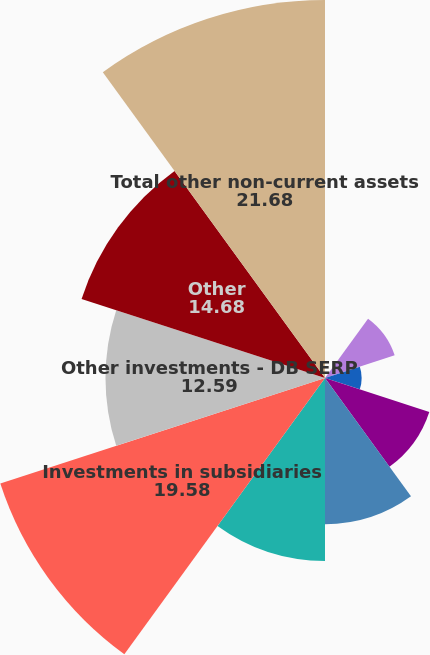Convert chart to OTSL. <chart><loc_0><loc_0><loc_500><loc_500><pie_chart><fcel>Notes and accrued interest<fcel>Accounts receivable including<fcel>Deferred income taxes<fcel>Total current assets<fcel>Plant property and equipment<fcel>Less accumulated depreciation<fcel>Investments in subsidiaries<fcel>Other investments - DB SERP<fcel>Other<fcel>Total other non-current assets<nl><fcel>0.0%<fcel>4.2%<fcel>2.1%<fcel>6.29%<fcel>8.39%<fcel>10.49%<fcel>19.58%<fcel>12.59%<fcel>14.68%<fcel>21.68%<nl></chart> 